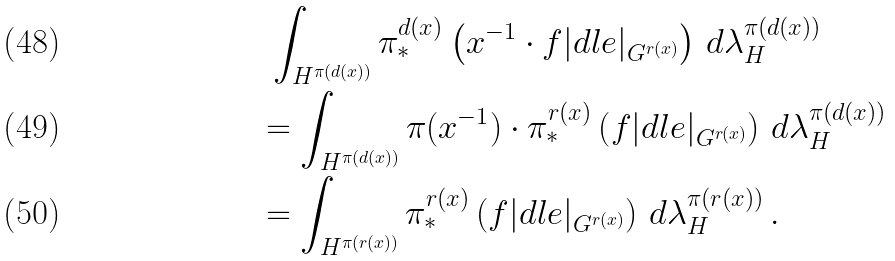<formula> <loc_0><loc_0><loc_500><loc_500>& \ \int _ { H ^ { \pi ( d ( x ) ) } } \pi _ { * } ^ { d ( x ) } \left ( x ^ { - 1 } \cdot f | d l e | _ { G ^ { r ( x ) } } \right ) \, d \lambda _ { H } ^ { \pi ( d ( x ) ) } \\ & = \int _ { H ^ { \pi ( d ( x ) ) } } \pi ( x ^ { - 1 } ) \cdot \pi _ { * } ^ { r ( x ) } \left ( f | d l e | _ { G ^ { r ( x ) } } \right ) \, d \lambda _ { H } ^ { \pi ( d ( x ) ) } \\ & = \int _ { H ^ { \pi ( r ( x ) ) } } \pi _ { * } ^ { r ( x ) } \left ( f | d l e | _ { G ^ { r ( x ) } } \right ) \, d \lambda _ { H } ^ { \pi ( r ( x ) ) } \, .</formula> 